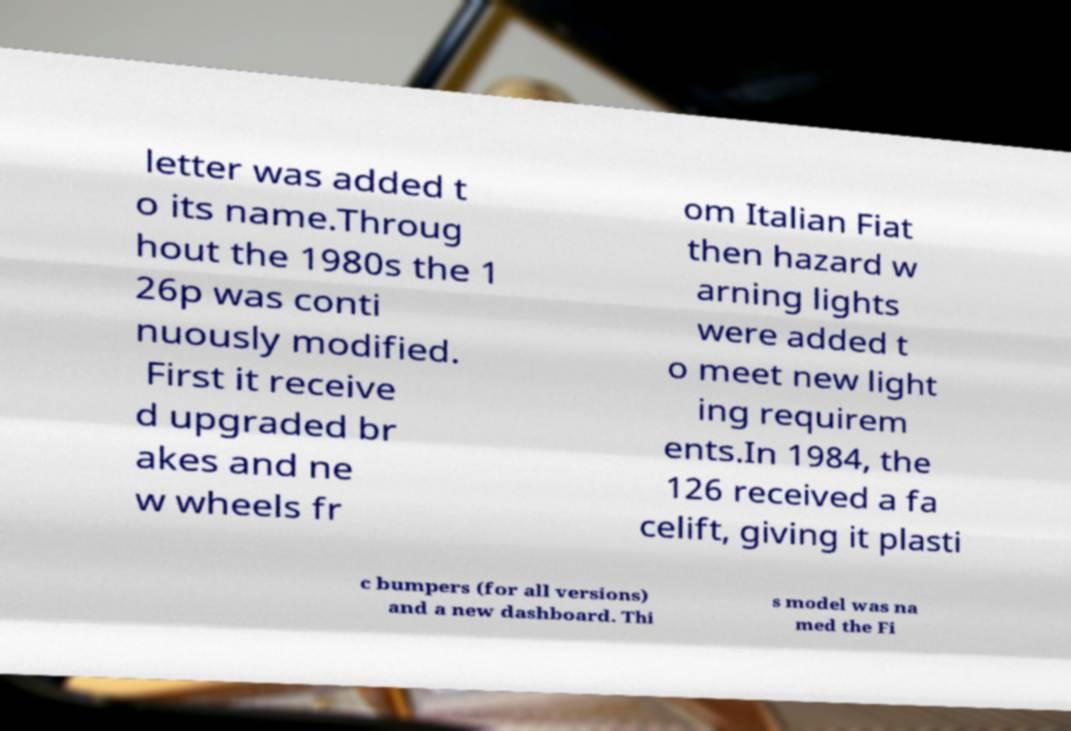Please read and relay the text visible in this image. What does it say? letter was added t o its name.Throug hout the 1980s the 1 26p was conti nuously modified. First it receive d upgraded br akes and ne w wheels fr om Italian Fiat then hazard w arning lights were added t o meet new light ing requirem ents.In 1984, the 126 received a fa celift, giving it plasti c bumpers (for all versions) and a new dashboard. Thi s model was na med the Fi 